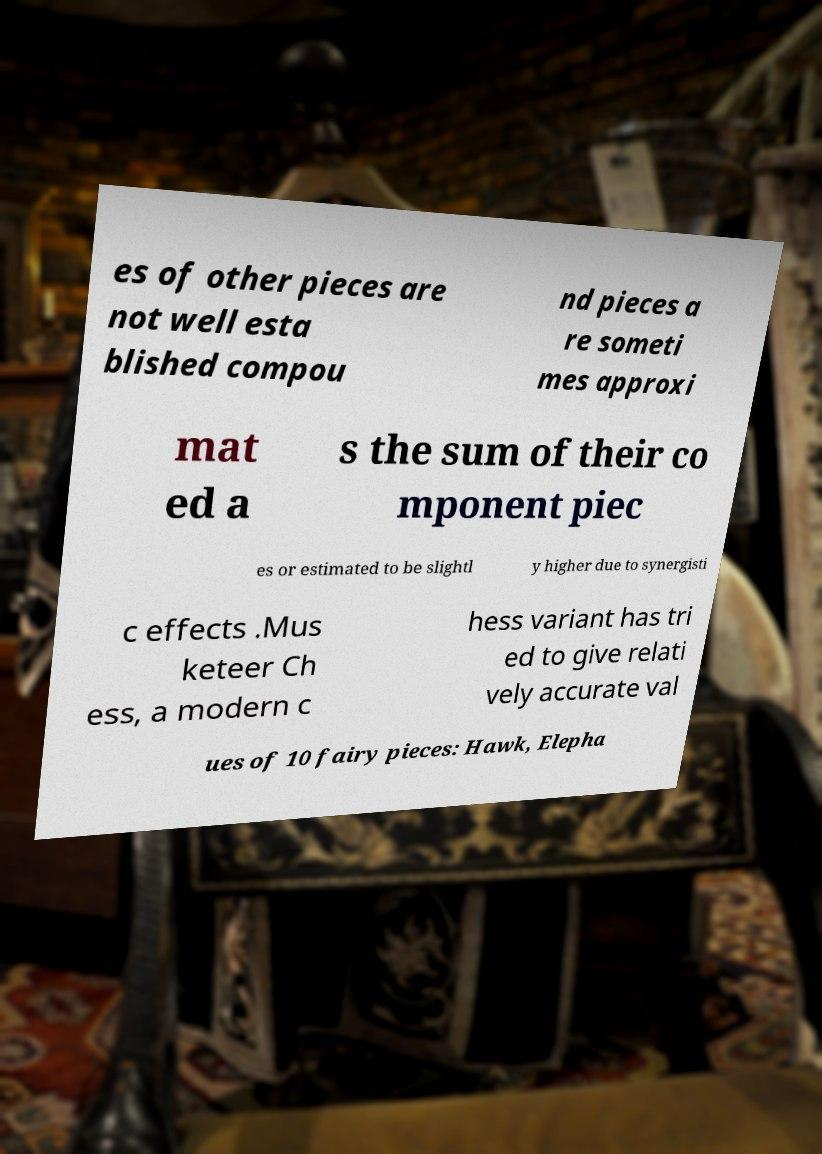What messages or text are displayed in this image? I need them in a readable, typed format. es of other pieces are not well esta blished compou nd pieces a re someti mes approxi mat ed a s the sum of their co mponent piec es or estimated to be slightl y higher due to synergisti c effects .Mus keteer Ch ess, a modern c hess variant has tri ed to give relati vely accurate val ues of 10 fairy pieces: Hawk, Elepha 